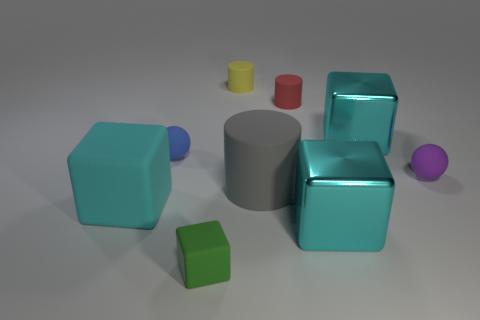Subtract all purple cylinders. How many cyan blocks are left? 3 Subtract 1 blocks. How many blocks are left? 3 Add 1 yellow rubber cylinders. How many objects exist? 10 Subtract all spheres. How many objects are left? 7 Subtract 0 yellow spheres. How many objects are left? 9 Subtract all tiny rubber spheres. Subtract all gray cylinders. How many objects are left? 6 Add 6 blue objects. How many blue objects are left? 7 Add 4 small yellow matte things. How many small yellow matte things exist? 5 